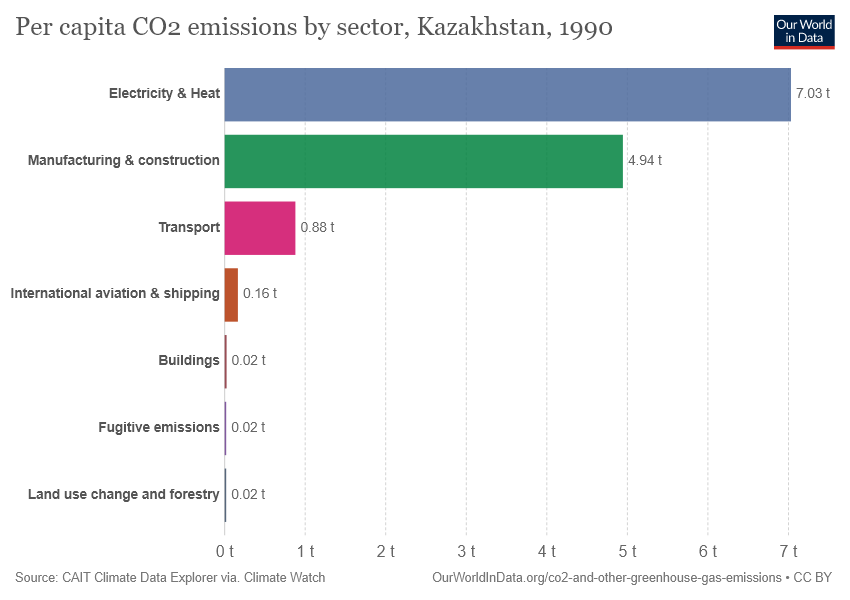Identify some key points in this picture. The light blue color bar is denoted by electricity and heat. The difference between the largest and smallest bars is 7.01. 